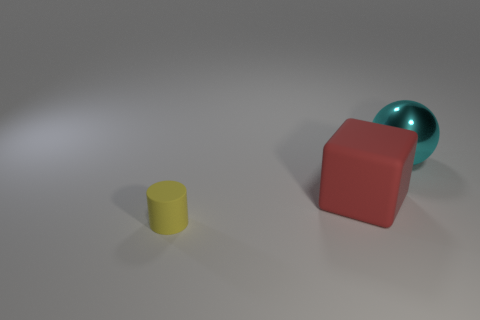Do the rubber thing that is to the right of the rubber cylinder and the matte cylinder have the same size?
Your response must be concise. No. How many objects are either things that are behind the tiny cylinder or things that are behind the cylinder?
Your answer should be very brief. 2. There is a rubber object to the right of the tiny rubber cylinder; is it the same color as the metallic object?
Make the answer very short. No. How many matte objects are tiny brown balls or cyan spheres?
Provide a short and direct response. 0. The large cyan shiny object is what shape?
Provide a succinct answer. Sphere. Are there any other things that are the same material as the yellow cylinder?
Offer a terse response. Yes. Is the red block made of the same material as the yellow thing?
Your answer should be very brief. Yes. Is there a red block that is on the left side of the small yellow object left of the rubber thing that is to the right of the small rubber thing?
Your answer should be very brief. No. How many other things are there of the same shape as the cyan metallic thing?
Provide a short and direct response. 0. The large object that is in front of the big object that is behind the matte object that is right of the small cylinder is what color?
Your response must be concise. Red. 